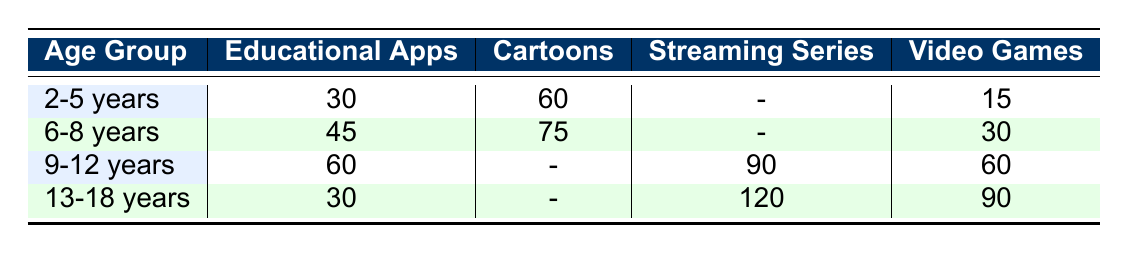What is the daily screen time for Educational Apps for children aged 6-8 years? The table shows that for the age group 6-8 years, the daily screen time for Educational Apps is 45 minutes.
Answer: 45 minutes How much time do children aged 2-5 years spend on Cartoons daily? Referring to the table, the screen time for children aged 2-5 years on Cartoons is 60 minutes.
Answer: 60 minutes Do children aged 9-12 years spend more time on Streaming Series than Video Games? Looking directly at the table, children aged 9-12 years spend 90 minutes on Streaming Series and 60 minutes on Video Games, confirming they spend more time on Streaming Series.
Answer: Yes Which age group has the highest daily screen time for Video Games? Referring to the table, children aged 13-18 years have the highest daily screen time for Video Games at 90 minutes.
Answer: 13-18 years What is the total daily screen time for Cartoons across all age groups? To find the total daily screen time for Cartoons, we sum the minutes: 60 (2-5) + 75 (6-8) + 0 (9-12) + 0 (13-18) = 135 minutes total.
Answer: 135 minutes Is it true that children aged 2-5 years spend more time on Educational Apps than on Video Games? In the table, children aged 2-5 years spend 30 minutes on Educational Apps and only 15 minutes on Video Games, so the statement is true.
Answer: Yes What is the average daily screen time for Streaming Series across all age groups? The only age group with Streaming Series is 9-12 years (90 minutes) and 13-18 years (120 minutes). The average is (90 + 120) / 2 = 105 minutes.
Answer: 105 minutes Which activity takes the least time for children in the age group of 2-5 years? Looking at the table, the least time for children aged 2-5 years is spent on Video Games, which is 15 minutes.
Answer: Video Games How much more time do children aged 6-8 years spend on Cartoons compared to Educational Apps? For children aged 6-8 years, they spend 75 minutes on Cartoons and 45 minutes on Educational Apps. The difference is 75 - 45 = 30 minutes more on Cartoons.
Answer: 30 minutes 